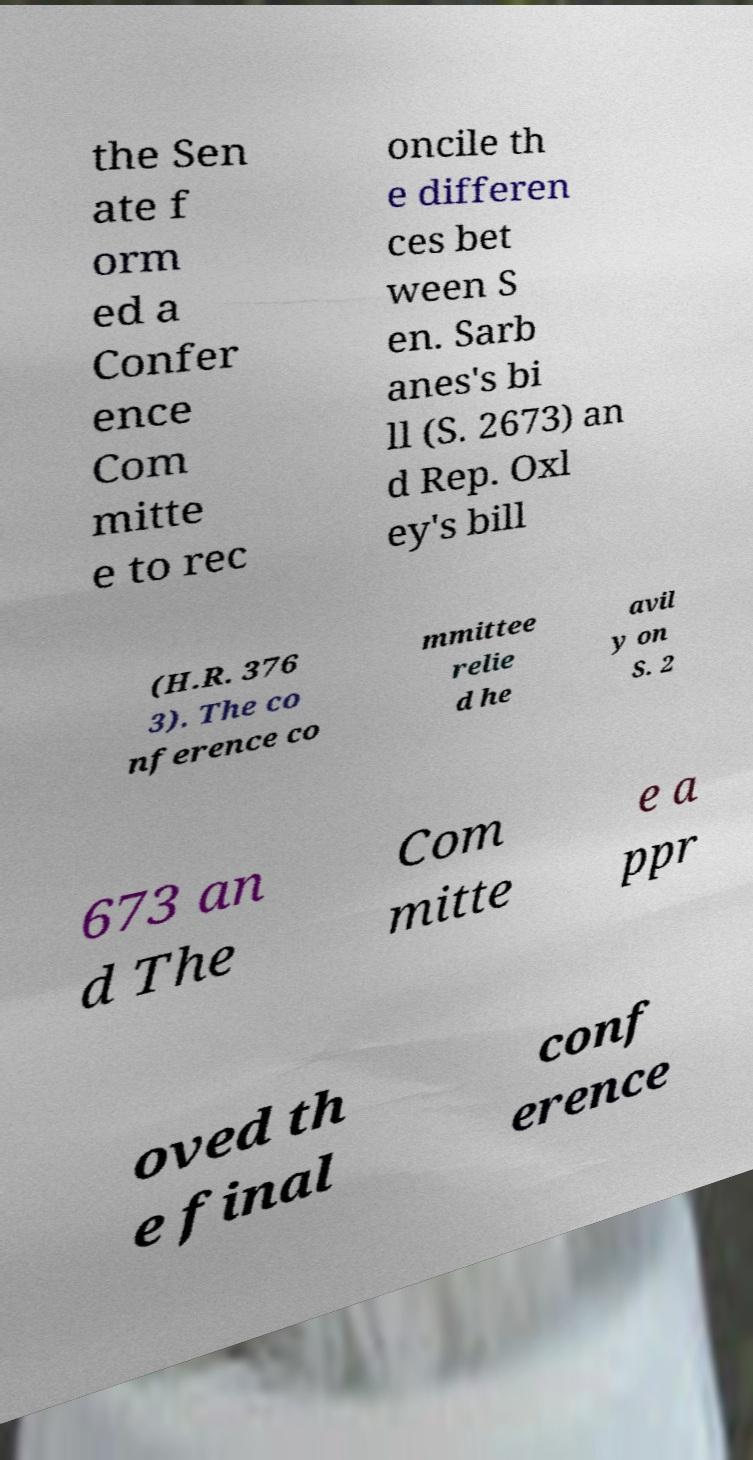Please identify and transcribe the text found in this image. the Sen ate f orm ed a Confer ence Com mitte e to rec oncile th e differen ces bet ween S en. Sarb anes's bi ll (S. 2673) an d Rep. Oxl ey's bill (H.R. 376 3). The co nference co mmittee relie d he avil y on S. 2 673 an d The Com mitte e a ppr oved th e final conf erence 